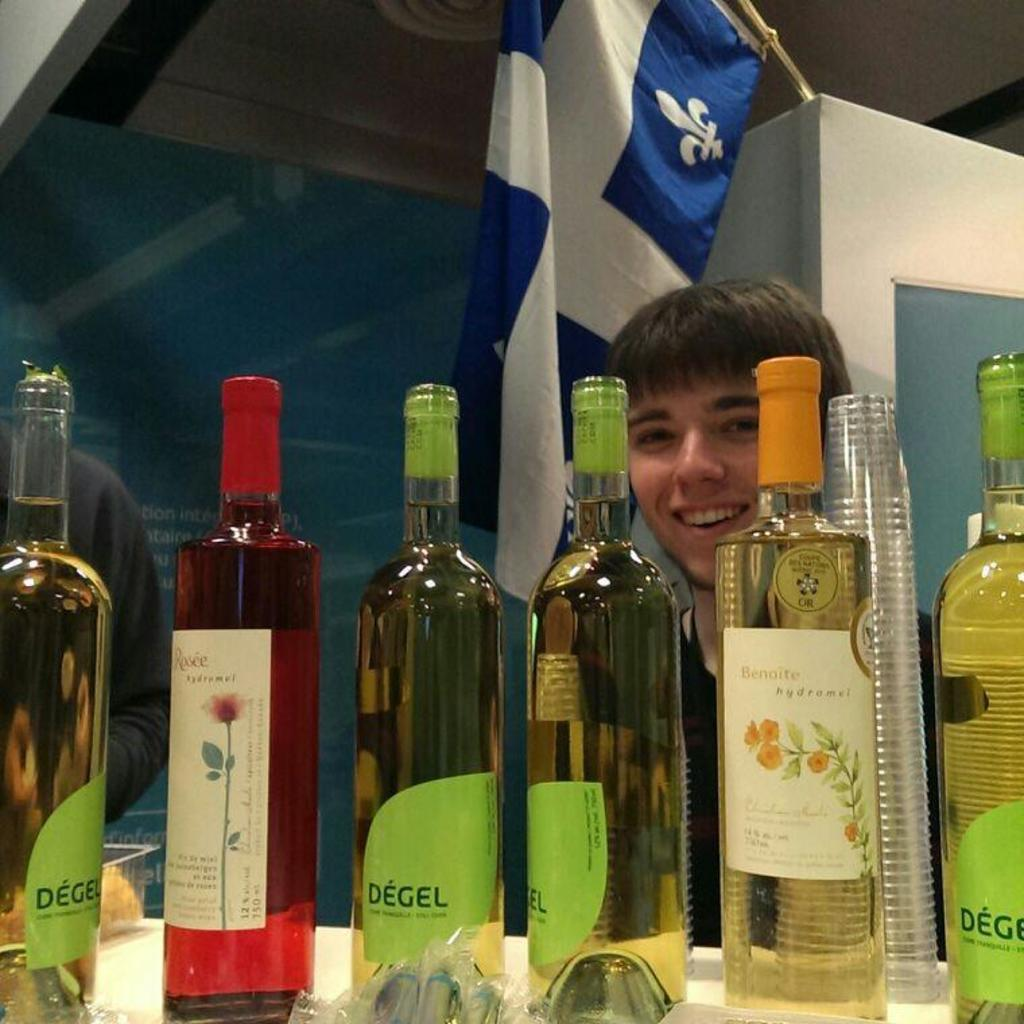<image>
Offer a succinct explanation of the picture presented. Man standing behind some bottles with one that says DEGEL. 